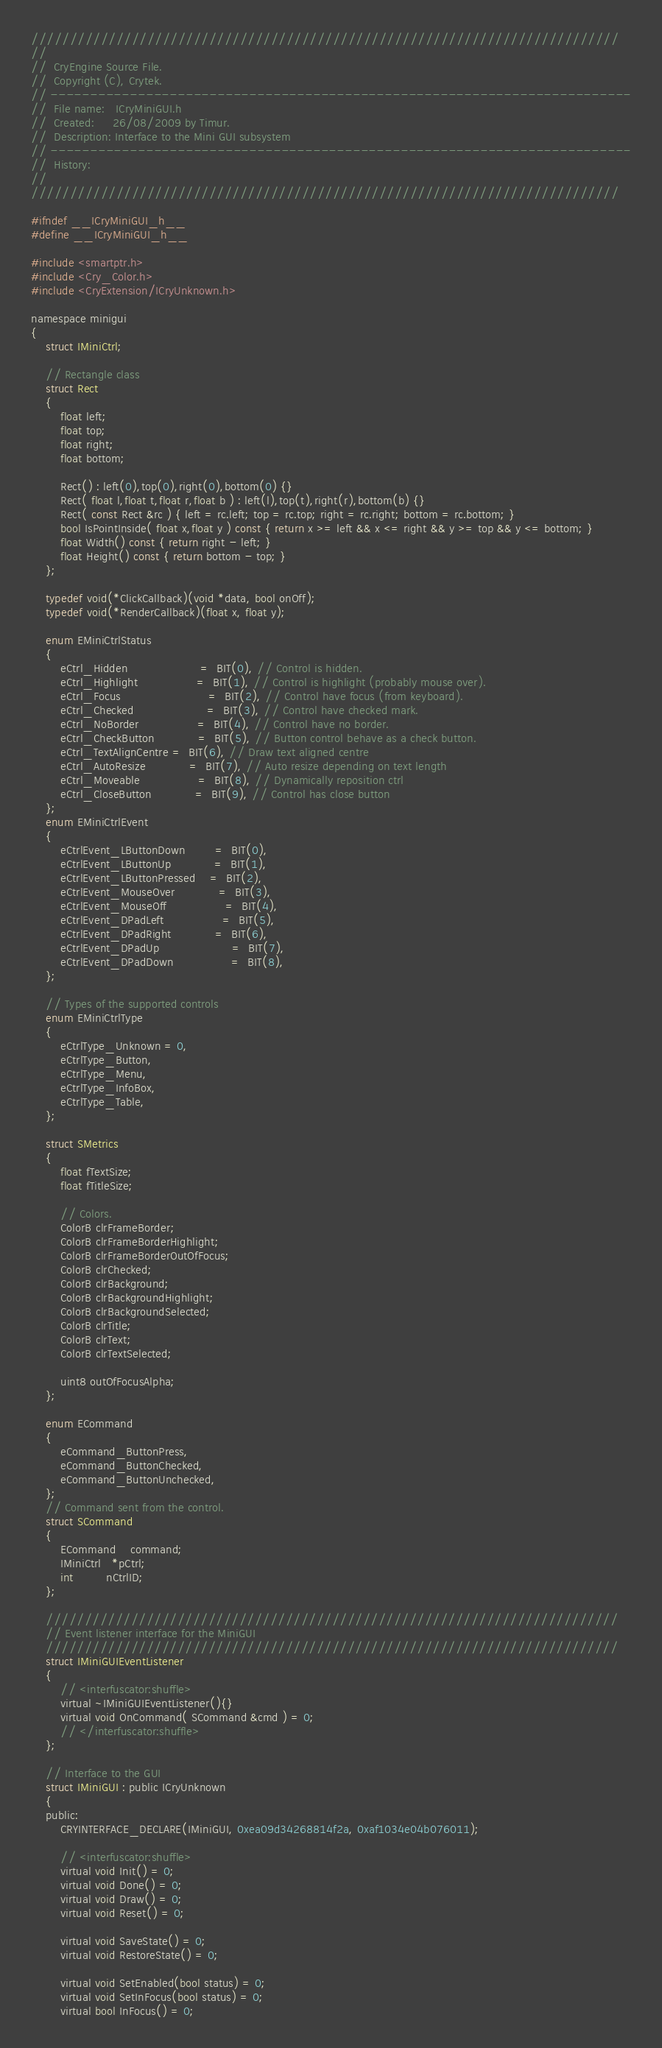<code> <loc_0><loc_0><loc_500><loc_500><_C_>////////////////////////////////////////////////////////////////////////////
//
//  CryEngine Source File.
//  Copyright (C), Crytek.
// -------------------------------------------------------------------------
//  File name:   ICryMiniGUI.h
//  Created:     26/08/2009 by Timur.
//  Description: Interface to the Mini GUI subsystem
// -------------------------------------------------------------------------
//  History:
//
////////////////////////////////////////////////////////////////////////////

#ifndef __ICryMiniGUI_h__
#define __ICryMiniGUI_h__

#include <smartptr.h>
#include <Cry_Color.h>
#include <CryExtension/ICryUnknown.h>

namespace minigui
{
	struct IMiniCtrl;

	// Rectangle class
	struct Rect
	{
		float left;
		float top;
		float right;
		float bottom;

		Rect() : left(0),top(0),right(0),bottom(0) {}
		Rect( float l,float t,float r,float b ) : left(l),top(t),right(r),bottom(b) {}
		Rect( const Rect &rc ) { left = rc.left; top = rc.top; right = rc.right; bottom = rc.bottom; }
		bool IsPointInside( float x,float y ) const { return x >= left && x <= right && y >= top && y <= bottom; }
		float Width() const { return right - left; }
		float Height() const { return bottom - top; }
	};

	typedef void(*ClickCallback)(void *data, bool onOff);
	typedef void(*RenderCallback)(float x, float y);

	enum EMiniCtrlStatus
	{
		eCtrl_Hidden					=  BIT(0), // Control is hidden.
		eCtrl_Highlight				=  BIT(1), // Control is highlight (probably mouse over).
		eCtrl_Focus						=  BIT(2), // Control have focus (from keyboard).
		eCtrl_Checked					=  BIT(3), // Control have checked mark.
		eCtrl_NoBorder				=  BIT(4), // Control have no border.
		eCtrl_CheckButton			=  BIT(5), // Button control behave as a check button.
		eCtrl_TextAlignCentre =  BIT(6), // Draw text aligned centre
		eCtrl_AutoResize			=  BIT(7), // Auto resize depending on text length
		eCtrl_Moveable				=  BIT(8), // Dynamically reposition ctrl
		eCtrl_CloseButton			=  BIT(9), // Control has close button
	};
	enum EMiniCtrlEvent
	{
		eCtrlEvent_LButtonDown		=  BIT(0),
		eCtrlEvent_LButtonUp			=  BIT(1),
		eCtrlEvent_LButtonPressed	=  BIT(2),
		eCtrlEvent_MouseOver			=  BIT(3),
		eCtrlEvent_MouseOff				=  BIT(4),
		eCtrlEvent_DPadLeft				=  BIT(5),
		eCtrlEvent_DPadRight			=  BIT(6),
		eCtrlEvent_DPadUp					=  BIT(7),
		eCtrlEvent_DPadDown				=  BIT(8),
	};

	// Types of the supported controls
	enum EMiniCtrlType
	{
		eCtrlType_Unknown = 0,
		eCtrlType_Button,
		eCtrlType_Menu,
		eCtrlType_InfoBox,
		eCtrlType_Table,
	};

	struct SMetrics
	{
		float fTextSize;
		float fTitleSize;

		// Colors.
		ColorB clrFrameBorder;
		ColorB clrFrameBorderHighlight;
		ColorB clrFrameBorderOutOfFocus;
		ColorB clrChecked;
		ColorB clrBackground;
		ColorB clrBackgroundHighlight;
		ColorB clrBackgroundSelected;
		ColorB clrTitle;
		ColorB clrText;
		ColorB clrTextSelected;

		uint8 outOfFocusAlpha;
	};

	enum ECommand
	{
		eCommand_ButtonPress,
		eCommand_ButtonChecked,
		eCommand_ButtonUnchecked,
	};
	// Command sent from the control.
	struct SCommand
	{
		ECommand    command;
		IMiniCtrl   *pCtrl;
		int         nCtrlID;
	};

	//////////////////////////////////////////////////////////////////////////
	// Event listener interface for the MiniGUI
	//////////////////////////////////////////////////////////////////////////
	struct IMiniGUIEventListener
	{
		// <interfuscator:shuffle>
		virtual ~IMiniGUIEventListener(){}
		virtual void OnCommand( SCommand &cmd ) = 0;
		// </interfuscator:shuffle>
	};

	// Interface to the GUI
	struct IMiniGUI : public ICryUnknown
	{
	public:
		CRYINTERFACE_DECLARE(IMiniGUI, 0xea09d34268814f2a, 0xaf1034e04b076011);

		// <interfuscator:shuffle>
		virtual void Init() = 0;
		virtual void Done() = 0;
		virtual void Draw() = 0;
		virtual void Reset() = 0;
		
		virtual void SaveState() = 0;
		virtual void RestoreState() = 0;

		virtual void SetEnabled(bool status) = 0;
		virtual void SetInFocus(bool status) = 0;
		virtual bool InFocus() = 0;
</code> 